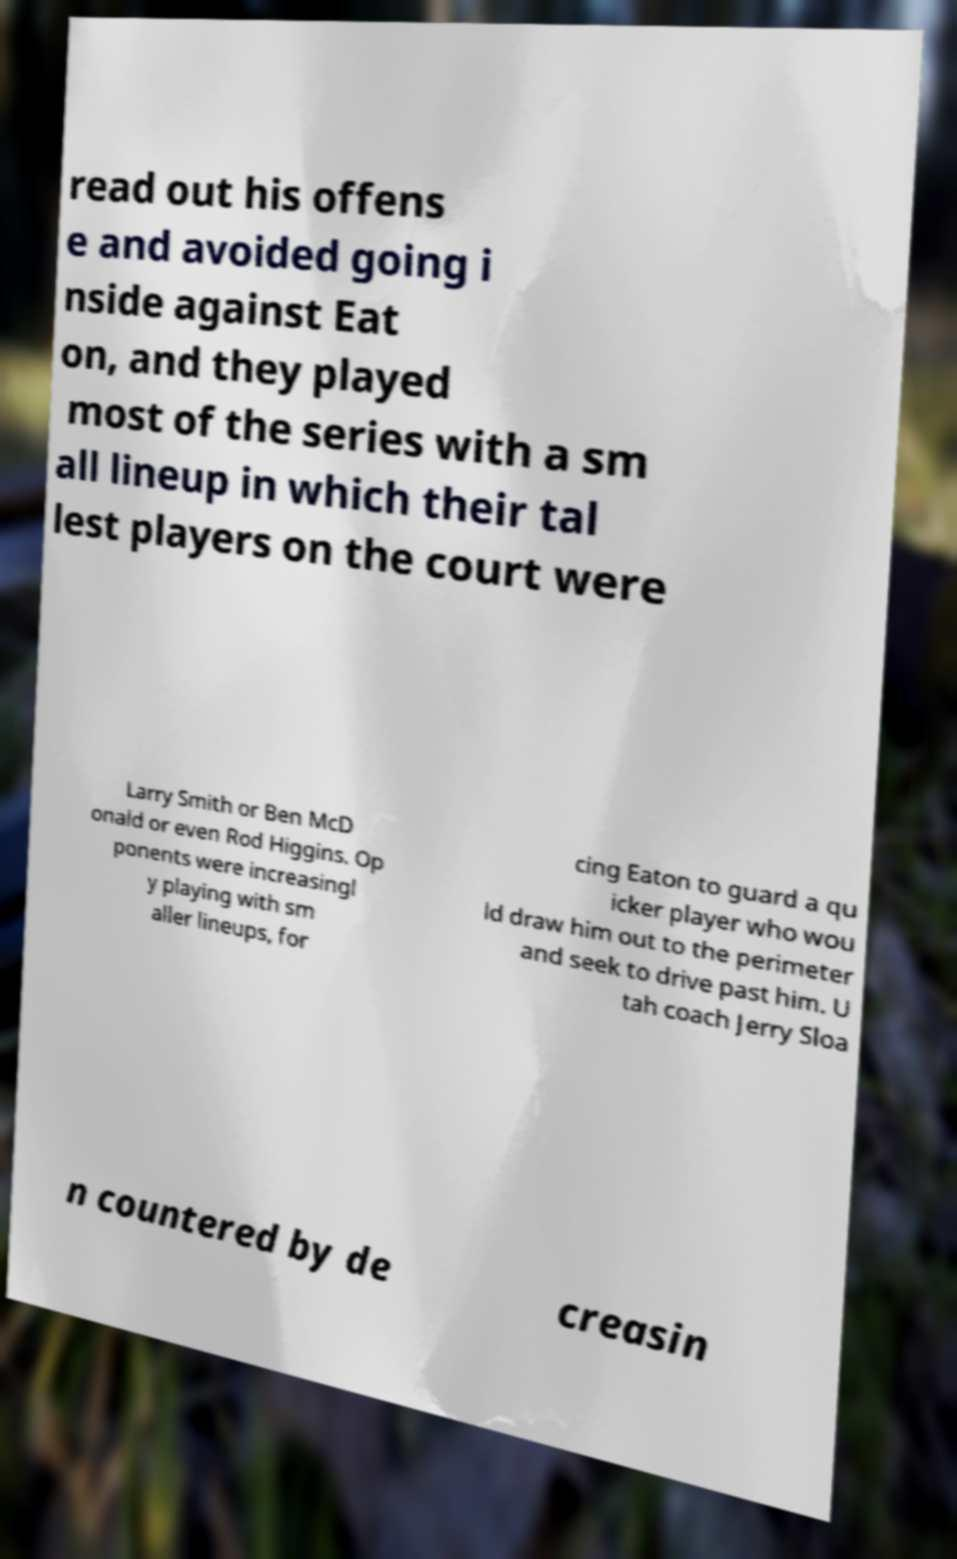Could you extract and type out the text from this image? read out his offens e and avoided going i nside against Eat on, and they played most of the series with a sm all lineup in which their tal lest players on the court were Larry Smith or Ben McD onald or even Rod Higgins. Op ponents were increasingl y playing with sm aller lineups, for cing Eaton to guard a qu icker player who wou ld draw him out to the perimeter and seek to drive past him. U tah coach Jerry Sloa n countered by de creasin 